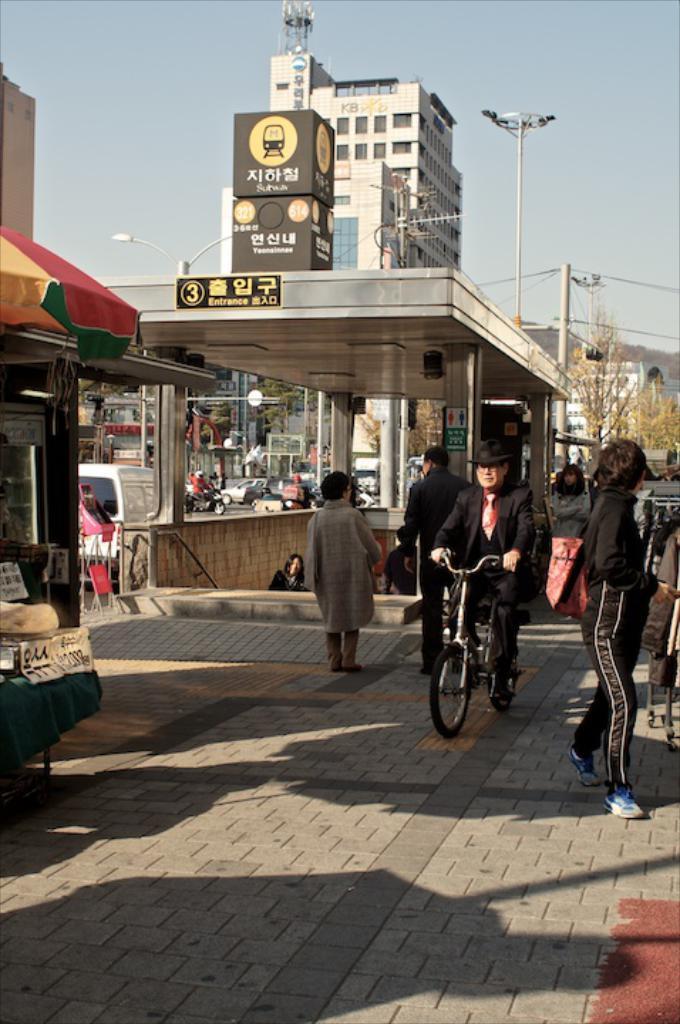How would you summarize this image in a sentence or two? In this image there is the sky towards the top of the image, there are buildings, there are persons walking, there is a man riding a bicycle, there is an umbrella towards the left of the image, there are objects towards the left of the image, there are trees towards the right of the image, there are objects towards the right of the image, there is ground towards the bottom of the image, there are poles, there are lights, there are boards, there is text on the boards, there is road, there are vehicles on the road. 